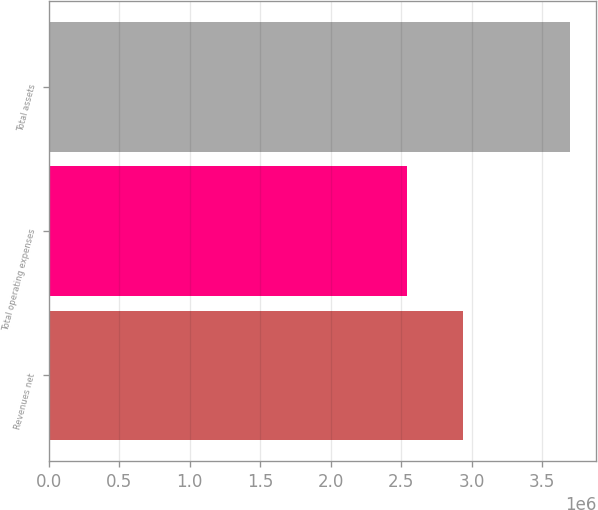<chart> <loc_0><loc_0><loc_500><loc_500><bar_chart><fcel>Revenues net<fcel>Total operating expenses<fcel>Total assets<nl><fcel>2.93763e+06<fcel>2.54444e+06<fcel>3.70054e+06<nl></chart> 